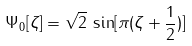Convert formula to latex. <formula><loc_0><loc_0><loc_500><loc_500>\Psi _ { 0 } [ \zeta ] = \sqrt { 2 } \, \sin [ \pi ( \zeta + \frac { 1 } { 2 } ) ]</formula> 